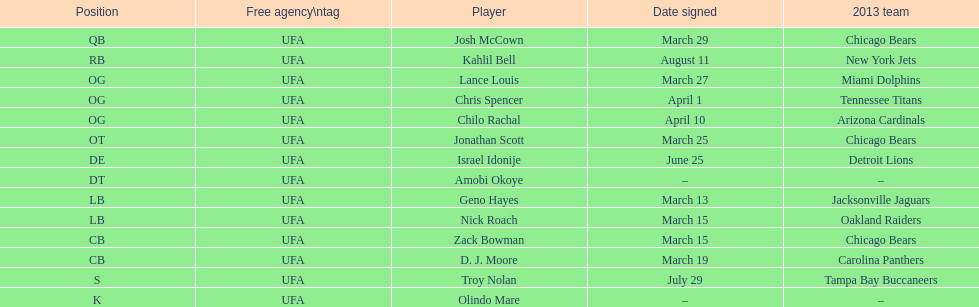Signed the same date as "april fools day". Chris Spencer. 